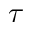<formula> <loc_0><loc_0><loc_500><loc_500>\tau</formula> 